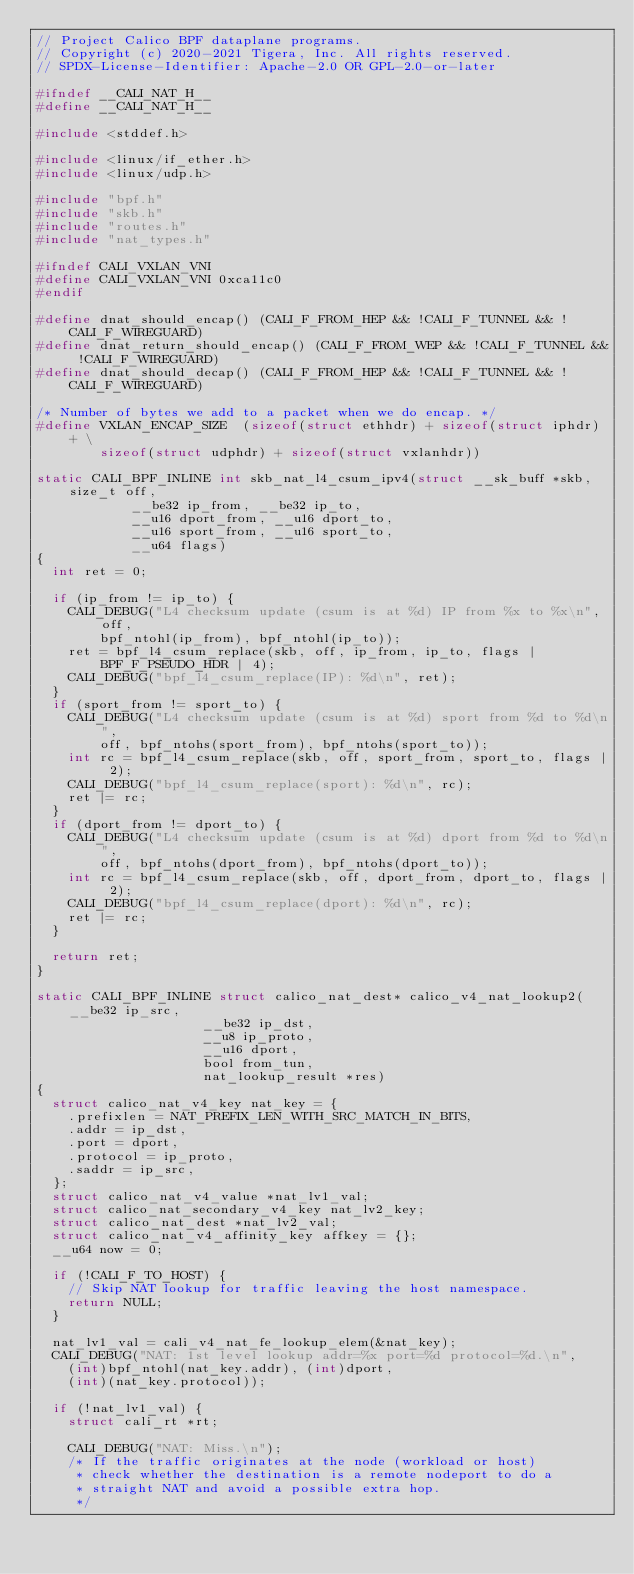<code> <loc_0><loc_0><loc_500><loc_500><_C_>// Project Calico BPF dataplane programs.
// Copyright (c) 2020-2021 Tigera, Inc. All rights reserved.
// SPDX-License-Identifier: Apache-2.0 OR GPL-2.0-or-later

#ifndef __CALI_NAT_H__
#define __CALI_NAT_H__

#include <stddef.h>

#include <linux/if_ether.h>
#include <linux/udp.h>

#include "bpf.h"
#include "skb.h"
#include "routes.h"
#include "nat_types.h"

#ifndef CALI_VXLAN_VNI
#define CALI_VXLAN_VNI 0xca11c0
#endif

#define dnat_should_encap() (CALI_F_FROM_HEP && !CALI_F_TUNNEL && !CALI_F_WIREGUARD)
#define dnat_return_should_encap() (CALI_F_FROM_WEP && !CALI_F_TUNNEL && !CALI_F_WIREGUARD)
#define dnat_should_decap() (CALI_F_FROM_HEP && !CALI_F_TUNNEL && !CALI_F_WIREGUARD)

/* Number of bytes we add to a packet when we do encap. */
#define VXLAN_ENCAP_SIZE	(sizeof(struct ethhdr) + sizeof(struct iphdr) + \
				sizeof(struct udphdr) + sizeof(struct vxlanhdr))

static CALI_BPF_INLINE int skb_nat_l4_csum_ipv4(struct __sk_buff *skb, size_t off,
						__be32 ip_from, __be32 ip_to,
						__u16 dport_from, __u16 dport_to,
						__u16 sport_from, __u16 sport_to,
						__u64 flags)
{
	int ret = 0;

	if (ip_from != ip_to) {
		CALI_DEBUG("L4 checksum update (csum is at %d) IP from %x to %x\n", off,
				bpf_ntohl(ip_from), bpf_ntohl(ip_to));
		ret = bpf_l4_csum_replace(skb, off, ip_from, ip_to, flags | BPF_F_PSEUDO_HDR | 4);
		CALI_DEBUG("bpf_l4_csum_replace(IP): %d\n", ret);
	}
	if (sport_from != sport_to) {
		CALI_DEBUG("L4 checksum update (csum is at %d) sport from %d to %d\n",
				off, bpf_ntohs(sport_from), bpf_ntohs(sport_to));
		int rc = bpf_l4_csum_replace(skb, off, sport_from, sport_to, flags | 2);
		CALI_DEBUG("bpf_l4_csum_replace(sport): %d\n", rc);
		ret |= rc;
	}
	if (dport_from != dport_to) {
		CALI_DEBUG("L4 checksum update (csum is at %d) dport from %d to %d\n",
				off, bpf_ntohs(dport_from), bpf_ntohs(dport_to));
		int rc = bpf_l4_csum_replace(skb, off, dport_from, dport_to, flags | 2);
		CALI_DEBUG("bpf_l4_csum_replace(dport): %d\n", rc);
		ret |= rc;
	}

	return ret;
}

static CALI_BPF_INLINE struct calico_nat_dest* calico_v4_nat_lookup2(__be32 ip_src,
								     __be32 ip_dst,
								     __u8 ip_proto,
								     __u16 dport,
								     bool from_tun,
								     nat_lookup_result *res)
{
	struct calico_nat_v4_key nat_key = {
		.prefixlen = NAT_PREFIX_LEN_WITH_SRC_MATCH_IN_BITS,
		.addr = ip_dst,
		.port = dport,
		.protocol = ip_proto,
		.saddr = ip_src,
	};
	struct calico_nat_v4_value *nat_lv1_val;
	struct calico_nat_secondary_v4_key nat_lv2_key;
	struct calico_nat_dest *nat_lv2_val;
	struct calico_nat_v4_affinity_key affkey = {};
	__u64 now = 0;

	if (!CALI_F_TO_HOST) {
		// Skip NAT lookup for traffic leaving the host namespace.
		return NULL;
	}

	nat_lv1_val = cali_v4_nat_fe_lookup_elem(&nat_key);
	CALI_DEBUG("NAT: 1st level lookup addr=%x port=%d protocol=%d.\n",
		(int)bpf_ntohl(nat_key.addr), (int)dport,
		(int)(nat_key.protocol));

	if (!nat_lv1_val) {
		struct cali_rt *rt;

		CALI_DEBUG("NAT: Miss.\n");
		/* If the traffic originates at the node (workload or host)
		 * check whether the destination is a remote nodeport to do a
		 * straight NAT and avoid a possible extra hop.
		 */</code> 